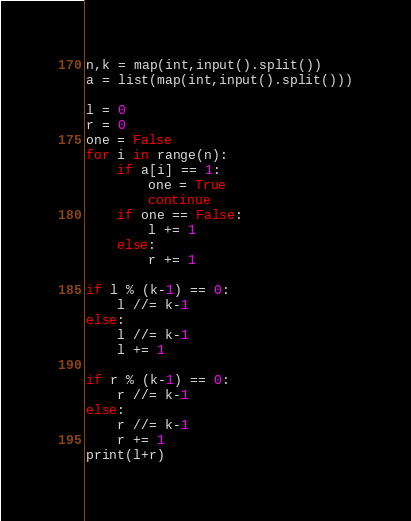<code> <loc_0><loc_0><loc_500><loc_500><_Python_>n,k = map(int,input().split())
a = list(map(int,input().split()))

l = 0
r = 0
one = False
for i in range(n):
    if a[i] == 1:
        one = True
        continue
    if one == False:
        l += 1
    else:
        r += 1

if l % (k-1) == 0:
    l //= k-1
else:
    l //= k-1
    l += 1
    
if r % (k-1) == 0:
    r //= k-1
else:
    r //= k-1
    r += 1
print(l+r)</code> 